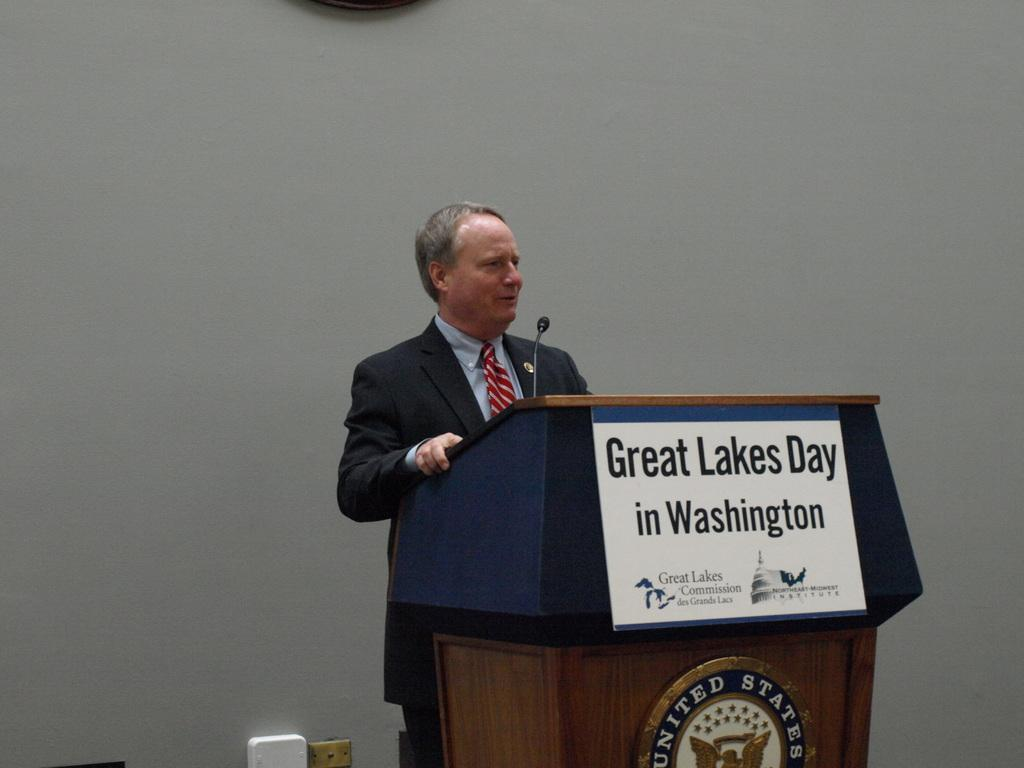<image>
Share a concise interpretation of the image provided. man speaking at podium for great lakes day in washington 